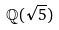<formula> <loc_0><loc_0><loc_500><loc_500>\mathbb { Q } ( \sqrt { 5 } )</formula> 